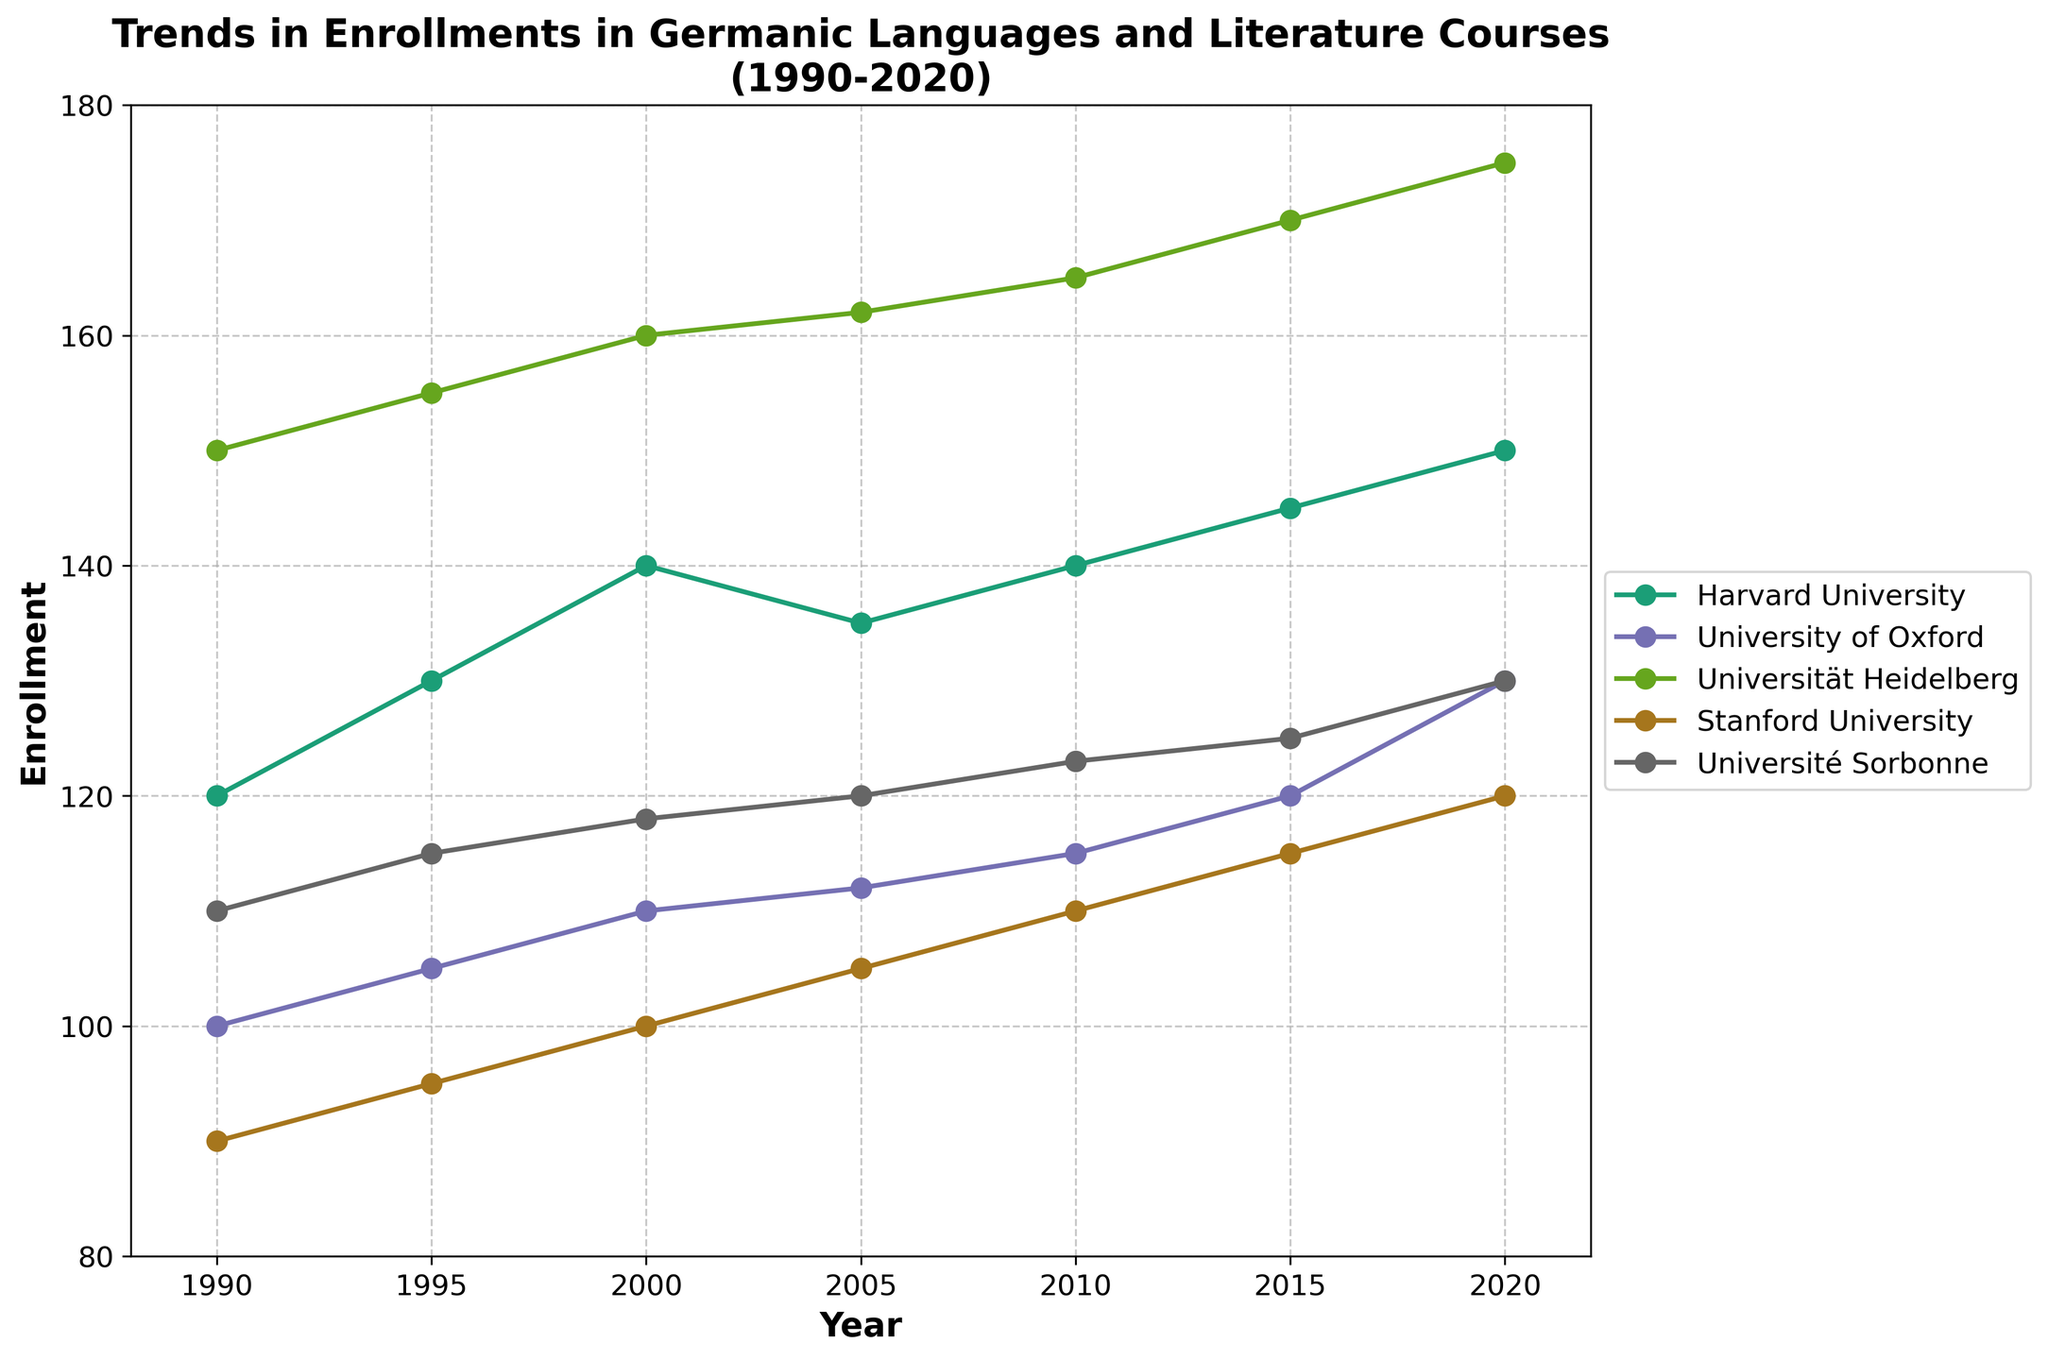What is the title of the figure? The title of the figure is prominently displayed at the top and often summarizes the content of the plot. In this case, it states the general topic and timeframe being analyzed.
Answer: Trends in Enrollments in Germanic Languages and Literature Courses (1990-2020) What is the enrollment trend for Universität Heidelberg from 1990 to 2020? By observing the individual line plotted for Universität Heidelberg, one can see the changes in enrollment numbers over the specified years.
Answer: Increasing trend Which university had the highest enrollment in 2020? To find this, you identify the enrollment values for all universities in 2020 and determine the maximum. Universität Heidelberg has the highest mark in 2020.
Answer: Universität Heidelberg Did any university have a decline in enrollments between any two consecutive years? Look at the plot lines for any downward trends between two consecutive points for each university. Harvard University shows a dip from 2000 to 2005.
Answer: Yes, Harvard University How does the enrollment trend of Stanford University compare to that of Université Sorbonne? By comparing the lines representing Stanford University and Université Sorbonne, you can see they follow similar, somewhat steady and slightly increasing trends over time.
Answer: They both show a similar and relatively steady increasing trend What is the total enrollment for Harvard University over the years provided? Add the enrollment numbers for Harvard University for all the years listed: 120 + 130 + 140 + 135 + 140 + 145 + 150 = 960.
Answer: 960 In which year did University of Oxford see the highest increase in enrollments compared to the previous recorded year? Calculate the differences in enrollments between consecutive years for University of Oxford, identifying the highest increment. The largest change is from 2015 to 2020, where it increased by 10.
Answer: 2020 What was enrollment at Université Sorbonne in 2005? Locate the data point corresponding to Université Sorbonne and the year 2005 on the plot and read the enrollment value.
Answer: 120 Which university showed the most consistent (least variable) trend in enrollments over the years? Check all universities' lines for fluctuations. The university with the smoothest, least varied line, indicating consistency, is Universität Heidelberg.
Answer: Universität Heidelberg What is the average enrollment for University of Oxford across all recorded years? Add the enrollment numbers for all recorded years and divide by the number of years (100 + 105 + 110 + 112 + 115 + 120 + 130) / 7 = 792 / 7.
Answer: 113 